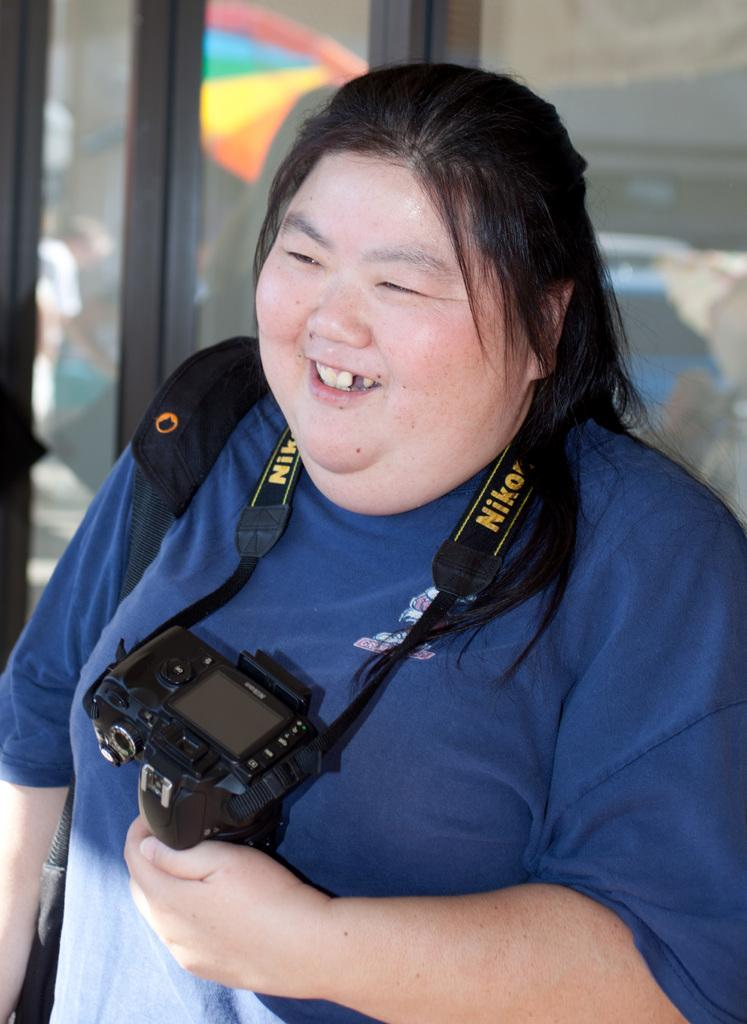Who is the main subject in the image? There is a lady in the center of the image. What is the lady holding in her hand? The lady is holding a camera in her hand. What can be seen behind the lady? There are windows behind the lady. What is the lady's facial expression in the image? The lady is smiling. How many degrees does the doll have in the image? There is no doll present in the image, so the question cannot be answered. What are the boys doing in the image? There are no boys present in the image, so the question cannot be answered. 